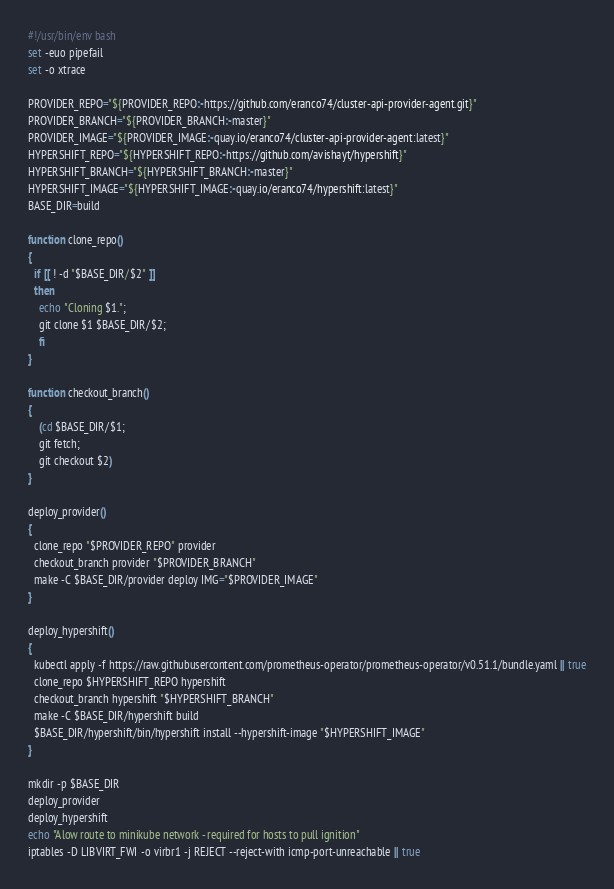<code> <loc_0><loc_0><loc_500><loc_500><_Bash_>#!/usr/bin/env bash
set -euo pipefail
set -o xtrace

PROVIDER_REPO="${PROVIDER_REPO:-https://github.com/eranco74/cluster-api-provider-agent.git}"
PROVIDER_BRANCH="${PROVIDER_BRANCH:-master}"
PROVIDER_IMAGE="${PROVIDER_IMAGE:-quay.io/eranco74/cluster-api-provider-agent:latest}"
HYPERSHIFT_REPO="${HYPERSHIFT_REPO:-https://github.com/avishayt/hypershift}"
HYPERSHIFT_BRANCH="${HYPERSHIFT_BRANCH:-master}"
HYPERSHIFT_IMAGE="${HYPERSHIFT_IMAGE:-quay.io/eranco74/hypershift:latest}"
BASE_DIR=build

function clone_repo()
{
  if [[ ! -d "$BASE_DIR/$2" ]]
  then
    echo "Cloning $1.";
    git clone $1 $BASE_DIR/$2;
	fi
}

function checkout_branch()
{
  	(cd $BASE_DIR/$1;
  	git fetch;
  	git checkout $2)
}

deploy_provider()
{
  clone_repo "$PROVIDER_REPO" provider
  checkout_branch provider "$PROVIDER_BRANCH"
  make -C $BASE_DIR/provider deploy IMG="$PROVIDER_IMAGE"
}

deploy_hypershift()
{
  kubectl apply -f https://raw.githubusercontent.com/prometheus-operator/prometheus-operator/v0.51.1/bundle.yaml || true
  clone_repo $HYPERSHIFT_REPO hypershift
  checkout_branch hypershift "$HYPERSHIFT_BRANCH"
  make -C $BASE_DIR/hypershift build
  $BASE_DIR/hypershift/bin/hypershift install --hypershift-image "$HYPERSHIFT_IMAGE"
}

mkdir -p $BASE_DIR
deploy_provider
deploy_hypershift
echo "Alow route to minikube network - required for hosts to pull ignition"
iptables -D LIBVIRT_FWI -o virbr1 -j REJECT --reject-with icmp-port-unreachable || true
</code> 